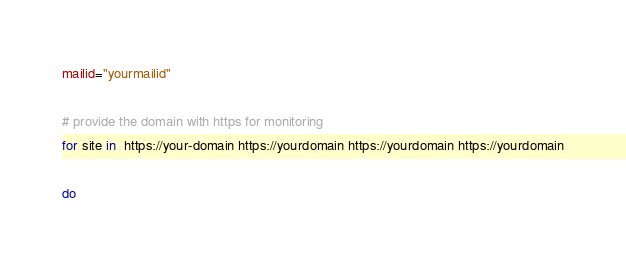Convert code to text. <code><loc_0><loc_0><loc_500><loc_500><_Bash_>mailid="yourmailid"

# provide the domain with https for monitoring
for site in  https://your-domain https://yourdomain https://yourdomain https://yourdomain

do
</code> 